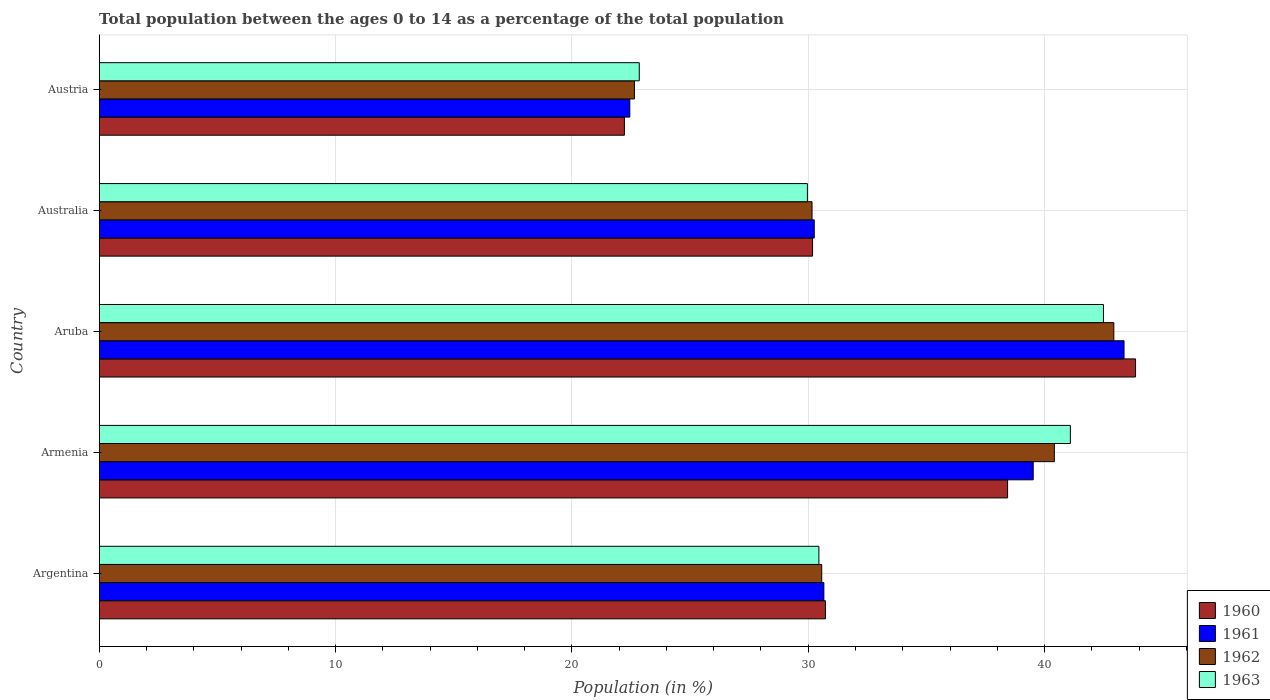How many different coloured bars are there?
Offer a very short reply. 4. How many bars are there on the 3rd tick from the bottom?
Keep it short and to the point. 4. What is the label of the 4th group of bars from the top?
Your answer should be compact. Armenia. What is the percentage of the population ages 0 to 14 in 1961 in Austria?
Offer a terse response. 22.45. Across all countries, what is the maximum percentage of the population ages 0 to 14 in 1962?
Provide a succinct answer. 42.93. Across all countries, what is the minimum percentage of the population ages 0 to 14 in 1962?
Your answer should be compact. 22.64. In which country was the percentage of the population ages 0 to 14 in 1961 maximum?
Offer a very short reply. Aruba. In which country was the percentage of the population ages 0 to 14 in 1960 minimum?
Ensure brevity in your answer.  Austria. What is the total percentage of the population ages 0 to 14 in 1960 in the graph?
Your response must be concise. 165.41. What is the difference between the percentage of the population ages 0 to 14 in 1960 in Armenia and that in Aruba?
Your answer should be very brief. -5.41. What is the difference between the percentage of the population ages 0 to 14 in 1960 in Argentina and the percentage of the population ages 0 to 14 in 1963 in Australia?
Ensure brevity in your answer.  0.76. What is the average percentage of the population ages 0 to 14 in 1963 per country?
Your response must be concise. 33.37. What is the difference between the percentage of the population ages 0 to 14 in 1963 and percentage of the population ages 0 to 14 in 1960 in Argentina?
Your answer should be very brief. -0.28. What is the ratio of the percentage of the population ages 0 to 14 in 1960 in Argentina to that in Armenia?
Offer a terse response. 0.8. Is the percentage of the population ages 0 to 14 in 1962 in Australia less than that in Austria?
Provide a succinct answer. No. Is the difference between the percentage of the population ages 0 to 14 in 1963 in Armenia and Aruba greater than the difference between the percentage of the population ages 0 to 14 in 1960 in Armenia and Aruba?
Give a very brief answer. Yes. What is the difference between the highest and the second highest percentage of the population ages 0 to 14 in 1960?
Your answer should be compact. 5.41. What is the difference between the highest and the lowest percentage of the population ages 0 to 14 in 1963?
Ensure brevity in your answer.  19.64. In how many countries, is the percentage of the population ages 0 to 14 in 1961 greater than the average percentage of the population ages 0 to 14 in 1961 taken over all countries?
Make the answer very short. 2. How many bars are there?
Ensure brevity in your answer.  20. Are all the bars in the graph horizontal?
Offer a terse response. Yes. How many countries are there in the graph?
Your answer should be very brief. 5. Does the graph contain any zero values?
Provide a succinct answer. No. How are the legend labels stacked?
Your answer should be very brief. Vertical. What is the title of the graph?
Provide a succinct answer. Total population between the ages 0 to 14 as a percentage of the total population. Does "1998" appear as one of the legend labels in the graph?
Provide a short and direct response. No. What is the label or title of the X-axis?
Your answer should be compact. Population (in %). What is the label or title of the Y-axis?
Ensure brevity in your answer.  Country. What is the Population (in %) in 1960 in Argentina?
Ensure brevity in your answer.  30.73. What is the Population (in %) of 1961 in Argentina?
Your response must be concise. 30.66. What is the Population (in %) in 1962 in Argentina?
Keep it short and to the point. 30.57. What is the Population (in %) in 1963 in Argentina?
Your response must be concise. 30.45. What is the Population (in %) in 1960 in Armenia?
Your answer should be compact. 38.43. What is the Population (in %) of 1961 in Armenia?
Ensure brevity in your answer.  39.52. What is the Population (in %) in 1962 in Armenia?
Ensure brevity in your answer.  40.41. What is the Population (in %) of 1963 in Armenia?
Ensure brevity in your answer.  41.09. What is the Population (in %) in 1960 in Aruba?
Offer a very short reply. 43.85. What is the Population (in %) of 1961 in Aruba?
Provide a short and direct response. 43.36. What is the Population (in %) in 1962 in Aruba?
Make the answer very short. 42.93. What is the Population (in %) of 1963 in Aruba?
Your response must be concise. 42.49. What is the Population (in %) in 1960 in Australia?
Your answer should be compact. 30.18. What is the Population (in %) of 1961 in Australia?
Keep it short and to the point. 30.25. What is the Population (in %) in 1962 in Australia?
Give a very brief answer. 30.16. What is the Population (in %) of 1963 in Australia?
Provide a succinct answer. 29.96. What is the Population (in %) in 1960 in Austria?
Your answer should be very brief. 22.22. What is the Population (in %) in 1961 in Austria?
Provide a short and direct response. 22.45. What is the Population (in %) in 1962 in Austria?
Make the answer very short. 22.64. What is the Population (in %) in 1963 in Austria?
Offer a very short reply. 22.85. Across all countries, what is the maximum Population (in %) in 1960?
Provide a short and direct response. 43.85. Across all countries, what is the maximum Population (in %) of 1961?
Offer a terse response. 43.36. Across all countries, what is the maximum Population (in %) of 1962?
Provide a short and direct response. 42.93. Across all countries, what is the maximum Population (in %) of 1963?
Your answer should be compact. 42.49. Across all countries, what is the minimum Population (in %) in 1960?
Ensure brevity in your answer.  22.22. Across all countries, what is the minimum Population (in %) in 1961?
Keep it short and to the point. 22.45. Across all countries, what is the minimum Population (in %) of 1962?
Keep it short and to the point. 22.64. Across all countries, what is the minimum Population (in %) of 1963?
Offer a terse response. 22.85. What is the total Population (in %) in 1960 in the graph?
Provide a succinct answer. 165.41. What is the total Population (in %) of 1961 in the graph?
Your answer should be compact. 166.24. What is the total Population (in %) of 1962 in the graph?
Your answer should be very brief. 166.71. What is the total Population (in %) in 1963 in the graph?
Your answer should be compact. 166.84. What is the difference between the Population (in %) in 1960 in Argentina and that in Armenia?
Make the answer very short. -7.71. What is the difference between the Population (in %) of 1961 in Argentina and that in Armenia?
Your answer should be very brief. -8.86. What is the difference between the Population (in %) of 1962 in Argentina and that in Armenia?
Provide a succinct answer. -9.84. What is the difference between the Population (in %) in 1963 in Argentina and that in Armenia?
Give a very brief answer. -10.64. What is the difference between the Population (in %) of 1960 in Argentina and that in Aruba?
Offer a very short reply. -13.12. What is the difference between the Population (in %) in 1961 in Argentina and that in Aruba?
Provide a short and direct response. -12.7. What is the difference between the Population (in %) of 1962 in Argentina and that in Aruba?
Give a very brief answer. -12.36. What is the difference between the Population (in %) of 1963 in Argentina and that in Aruba?
Your answer should be compact. -12.04. What is the difference between the Population (in %) of 1960 in Argentina and that in Australia?
Give a very brief answer. 0.54. What is the difference between the Population (in %) of 1961 in Argentina and that in Australia?
Ensure brevity in your answer.  0.41. What is the difference between the Population (in %) in 1962 in Argentina and that in Australia?
Provide a succinct answer. 0.41. What is the difference between the Population (in %) in 1963 in Argentina and that in Australia?
Keep it short and to the point. 0.49. What is the difference between the Population (in %) in 1960 in Argentina and that in Austria?
Your response must be concise. 8.5. What is the difference between the Population (in %) of 1961 in Argentina and that in Austria?
Provide a succinct answer. 8.21. What is the difference between the Population (in %) in 1962 in Argentina and that in Austria?
Provide a short and direct response. 7.92. What is the difference between the Population (in %) in 1963 in Argentina and that in Austria?
Your answer should be very brief. 7.6. What is the difference between the Population (in %) in 1960 in Armenia and that in Aruba?
Your answer should be compact. -5.41. What is the difference between the Population (in %) in 1961 in Armenia and that in Aruba?
Provide a succinct answer. -3.84. What is the difference between the Population (in %) in 1962 in Armenia and that in Aruba?
Your response must be concise. -2.52. What is the difference between the Population (in %) in 1963 in Armenia and that in Aruba?
Ensure brevity in your answer.  -1.4. What is the difference between the Population (in %) in 1960 in Armenia and that in Australia?
Give a very brief answer. 8.25. What is the difference between the Population (in %) in 1961 in Armenia and that in Australia?
Your answer should be compact. 9.26. What is the difference between the Population (in %) of 1962 in Armenia and that in Australia?
Provide a short and direct response. 10.25. What is the difference between the Population (in %) of 1963 in Armenia and that in Australia?
Your answer should be compact. 11.13. What is the difference between the Population (in %) in 1960 in Armenia and that in Austria?
Provide a short and direct response. 16.21. What is the difference between the Population (in %) of 1961 in Armenia and that in Austria?
Offer a very short reply. 17.07. What is the difference between the Population (in %) in 1962 in Armenia and that in Austria?
Provide a succinct answer. 17.77. What is the difference between the Population (in %) of 1963 in Armenia and that in Austria?
Make the answer very short. 18.24. What is the difference between the Population (in %) in 1960 in Aruba and that in Australia?
Provide a short and direct response. 13.67. What is the difference between the Population (in %) of 1961 in Aruba and that in Australia?
Give a very brief answer. 13.11. What is the difference between the Population (in %) in 1962 in Aruba and that in Australia?
Give a very brief answer. 12.77. What is the difference between the Population (in %) in 1963 in Aruba and that in Australia?
Your answer should be very brief. 12.53. What is the difference between the Population (in %) of 1960 in Aruba and that in Austria?
Offer a very short reply. 21.63. What is the difference between the Population (in %) in 1961 in Aruba and that in Austria?
Offer a terse response. 20.91. What is the difference between the Population (in %) in 1962 in Aruba and that in Austria?
Offer a terse response. 20.28. What is the difference between the Population (in %) in 1963 in Aruba and that in Austria?
Ensure brevity in your answer.  19.64. What is the difference between the Population (in %) in 1960 in Australia and that in Austria?
Provide a short and direct response. 7.96. What is the difference between the Population (in %) of 1961 in Australia and that in Austria?
Give a very brief answer. 7.8. What is the difference between the Population (in %) of 1962 in Australia and that in Austria?
Give a very brief answer. 7.51. What is the difference between the Population (in %) of 1963 in Australia and that in Austria?
Give a very brief answer. 7.11. What is the difference between the Population (in %) of 1960 in Argentina and the Population (in %) of 1961 in Armenia?
Give a very brief answer. -8.79. What is the difference between the Population (in %) in 1960 in Argentina and the Population (in %) in 1962 in Armenia?
Provide a short and direct response. -9.69. What is the difference between the Population (in %) in 1960 in Argentina and the Population (in %) in 1963 in Armenia?
Offer a very short reply. -10.36. What is the difference between the Population (in %) of 1961 in Argentina and the Population (in %) of 1962 in Armenia?
Give a very brief answer. -9.75. What is the difference between the Population (in %) of 1961 in Argentina and the Population (in %) of 1963 in Armenia?
Your answer should be very brief. -10.43. What is the difference between the Population (in %) in 1962 in Argentina and the Population (in %) in 1963 in Armenia?
Give a very brief answer. -10.52. What is the difference between the Population (in %) in 1960 in Argentina and the Population (in %) in 1961 in Aruba?
Offer a terse response. -12.64. What is the difference between the Population (in %) of 1960 in Argentina and the Population (in %) of 1962 in Aruba?
Offer a terse response. -12.2. What is the difference between the Population (in %) of 1960 in Argentina and the Population (in %) of 1963 in Aruba?
Provide a short and direct response. -11.76. What is the difference between the Population (in %) of 1961 in Argentina and the Population (in %) of 1962 in Aruba?
Your answer should be very brief. -12.27. What is the difference between the Population (in %) of 1961 in Argentina and the Population (in %) of 1963 in Aruba?
Keep it short and to the point. -11.83. What is the difference between the Population (in %) in 1962 in Argentina and the Population (in %) in 1963 in Aruba?
Give a very brief answer. -11.92. What is the difference between the Population (in %) of 1960 in Argentina and the Population (in %) of 1961 in Australia?
Offer a very short reply. 0.47. What is the difference between the Population (in %) in 1960 in Argentina and the Population (in %) in 1962 in Australia?
Make the answer very short. 0.57. What is the difference between the Population (in %) in 1960 in Argentina and the Population (in %) in 1963 in Australia?
Your answer should be compact. 0.76. What is the difference between the Population (in %) of 1961 in Argentina and the Population (in %) of 1962 in Australia?
Ensure brevity in your answer.  0.5. What is the difference between the Population (in %) in 1961 in Argentina and the Population (in %) in 1963 in Australia?
Provide a short and direct response. 0.7. What is the difference between the Population (in %) in 1962 in Argentina and the Population (in %) in 1963 in Australia?
Provide a succinct answer. 0.61. What is the difference between the Population (in %) of 1960 in Argentina and the Population (in %) of 1961 in Austria?
Give a very brief answer. 8.28. What is the difference between the Population (in %) in 1960 in Argentina and the Population (in %) in 1962 in Austria?
Ensure brevity in your answer.  8.08. What is the difference between the Population (in %) in 1960 in Argentina and the Population (in %) in 1963 in Austria?
Provide a succinct answer. 7.88. What is the difference between the Population (in %) in 1961 in Argentina and the Population (in %) in 1962 in Austria?
Provide a short and direct response. 8.02. What is the difference between the Population (in %) of 1961 in Argentina and the Population (in %) of 1963 in Austria?
Offer a very short reply. 7.81. What is the difference between the Population (in %) of 1962 in Argentina and the Population (in %) of 1963 in Austria?
Give a very brief answer. 7.72. What is the difference between the Population (in %) in 1960 in Armenia and the Population (in %) in 1961 in Aruba?
Make the answer very short. -4.93. What is the difference between the Population (in %) of 1960 in Armenia and the Population (in %) of 1962 in Aruba?
Provide a succinct answer. -4.49. What is the difference between the Population (in %) in 1960 in Armenia and the Population (in %) in 1963 in Aruba?
Your response must be concise. -4.05. What is the difference between the Population (in %) of 1961 in Armenia and the Population (in %) of 1962 in Aruba?
Ensure brevity in your answer.  -3.41. What is the difference between the Population (in %) of 1961 in Armenia and the Population (in %) of 1963 in Aruba?
Provide a short and direct response. -2.97. What is the difference between the Population (in %) of 1962 in Armenia and the Population (in %) of 1963 in Aruba?
Ensure brevity in your answer.  -2.08. What is the difference between the Population (in %) in 1960 in Armenia and the Population (in %) in 1961 in Australia?
Provide a short and direct response. 8.18. What is the difference between the Population (in %) in 1960 in Armenia and the Population (in %) in 1962 in Australia?
Offer a very short reply. 8.27. What is the difference between the Population (in %) in 1960 in Armenia and the Population (in %) in 1963 in Australia?
Offer a very short reply. 8.47. What is the difference between the Population (in %) in 1961 in Armenia and the Population (in %) in 1962 in Australia?
Your answer should be very brief. 9.36. What is the difference between the Population (in %) in 1961 in Armenia and the Population (in %) in 1963 in Australia?
Your answer should be very brief. 9.55. What is the difference between the Population (in %) in 1962 in Armenia and the Population (in %) in 1963 in Australia?
Ensure brevity in your answer.  10.45. What is the difference between the Population (in %) in 1960 in Armenia and the Population (in %) in 1961 in Austria?
Your answer should be very brief. 15.98. What is the difference between the Population (in %) in 1960 in Armenia and the Population (in %) in 1962 in Austria?
Keep it short and to the point. 15.79. What is the difference between the Population (in %) of 1960 in Armenia and the Population (in %) of 1963 in Austria?
Your answer should be very brief. 15.58. What is the difference between the Population (in %) in 1961 in Armenia and the Population (in %) in 1962 in Austria?
Your response must be concise. 16.87. What is the difference between the Population (in %) of 1961 in Armenia and the Population (in %) of 1963 in Austria?
Give a very brief answer. 16.67. What is the difference between the Population (in %) of 1962 in Armenia and the Population (in %) of 1963 in Austria?
Ensure brevity in your answer.  17.56. What is the difference between the Population (in %) of 1960 in Aruba and the Population (in %) of 1961 in Australia?
Provide a succinct answer. 13.59. What is the difference between the Population (in %) in 1960 in Aruba and the Population (in %) in 1962 in Australia?
Offer a terse response. 13.69. What is the difference between the Population (in %) of 1960 in Aruba and the Population (in %) of 1963 in Australia?
Make the answer very short. 13.88. What is the difference between the Population (in %) of 1961 in Aruba and the Population (in %) of 1962 in Australia?
Provide a short and direct response. 13.2. What is the difference between the Population (in %) of 1961 in Aruba and the Population (in %) of 1963 in Australia?
Offer a very short reply. 13.4. What is the difference between the Population (in %) in 1962 in Aruba and the Population (in %) in 1963 in Australia?
Your answer should be very brief. 12.97. What is the difference between the Population (in %) in 1960 in Aruba and the Population (in %) in 1961 in Austria?
Your answer should be compact. 21.4. What is the difference between the Population (in %) in 1960 in Aruba and the Population (in %) in 1962 in Austria?
Your answer should be very brief. 21.2. What is the difference between the Population (in %) of 1960 in Aruba and the Population (in %) of 1963 in Austria?
Make the answer very short. 21. What is the difference between the Population (in %) in 1961 in Aruba and the Population (in %) in 1962 in Austria?
Your answer should be compact. 20.72. What is the difference between the Population (in %) of 1961 in Aruba and the Population (in %) of 1963 in Austria?
Ensure brevity in your answer.  20.51. What is the difference between the Population (in %) in 1962 in Aruba and the Population (in %) in 1963 in Austria?
Provide a succinct answer. 20.08. What is the difference between the Population (in %) in 1960 in Australia and the Population (in %) in 1961 in Austria?
Your answer should be very brief. 7.73. What is the difference between the Population (in %) of 1960 in Australia and the Population (in %) of 1962 in Austria?
Make the answer very short. 7.54. What is the difference between the Population (in %) in 1960 in Australia and the Population (in %) in 1963 in Austria?
Keep it short and to the point. 7.33. What is the difference between the Population (in %) of 1961 in Australia and the Population (in %) of 1962 in Austria?
Give a very brief answer. 7.61. What is the difference between the Population (in %) in 1961 in Australia and the Population (in %) in 1963 in Austria?
Your answer should be compact. 7.4. What is the difference between the Population (in %) in 1962 in Australia and the Population (in %) in 1963 in Austria?
Make the answer very short. 7.31. What is the average Population (in %) of 1960 per country?
Offer a terse response. 33.08. What is the average Population (in %) of 1961 per country?
Your answer should be compact. 33.25. What is the average Population (in %) in 1962 per country?
Ensure brevity in your answer.  33.34. What is the average Population (in %) of 1963 per country?
Ensure brevity in your answer.  33.37. What is the difference between the Population (in %) of 1960 and Population (in %) of 1961 in Argentina?
Offer a very short reply. 0.07. What is the difference between the Population (in %) of 1960 and Population (in %) of 1962 in Argentina?
Ensure brevity in your answer.  0.16. What is the difference between the Population (in %) in 1960 and Population (in %) in 1963 in Argentina?
Provide a short and direct response. 0.28. What is the difference between the Population (in %) in 1961 and Population (in %) in 1962 in Argentina?
Give a very brief answer. 0.09. What is the difference between the Population (in %) of 1961 and Population (in %) of 1963 in Argentina?
Offer a very short reply. 0.21. What is the difference between the Population (in %) of 1962 and Population (in %) of 1963 in Argentina?
Your response must be concise. 0.12. What is the difference between the Population (in %) in 1960 and Population (in %) in 1961 in Armenia?
Keep it short and to the point. -1.08. What is the difference between the Population (in %) of 1960 and Population (in %) of 1962 in Armenia?
Provide a succinct answer. -1.98. What is the difference between the Population (in %) in 1960 and Population (in %) in 1963 in Armenia?
Offer a very short reply. -2.66. What is the difference between the Population (in %) of 1961 and Population (in %) of 1962 in Armenia?
Your answer should be compact. -0.89. What is the difference between the Population (in %) in 1961 and Population (in %) in 1963 in Armenia?
Offer a very short reply. -1.57. What is the difference between the Population (in %) of 1962 and Population (in %) of 1963 in Armenia?
Offer a terse response. -0.68. What is the difference between the Population (in %) in 1960 and Population (in %) in 1961 in Aruba?
Your response must be concise. 0.49. What is the difference between the Population (in %) in 1960 and Population (in %) in 1962 in Aruba?
Provide a short and direct response. 0.92. What is the difference between the Population (in %) in 1960 and Population (in %) in 1963 in Aruba?
Provide a succinct answer. 1.36. What is the difference between the Population (in %) of 1961 and Population (in %) of 1962 in Aruba?
Your answer should be compact. 0.43. What is the difference between the Population (in %) of 1961 and Population (in %) of 1963 in Aruba?
Provide a short and direct response. 0.87. What is the difference between the Population (in %) of 1962 and Population (in %) of 1963 in Aruba?
Make the answer very short. 0.44. What is the difference between the Population (in %) in 1960 and Population (in %) in 1961 in Australia?
Provide a short and direct response. -0.07. What is the difference between the Population (in %) in 1960 and Population (in %) in 1962 in Australia?
Your response must be concise. 0.02. What is the difference between the Population (in %) in 1960 and Population (in %) in 1963 in Australia?
Provide a succinct answer. 0.22. What is the difference between the Population (in %) of 1961 and Population (in %) of 1962 in Australia?
Give a very brief answer. 0.09. What is the difference between the Population (in %) of 1961 and Population (in %) of 1963 in Australia?
Ensure brevity in your answer.  0.29. What is the difference between the Population (in %) in 1962 and Population (in %) in 1963 in Australia?
Make the answer very short. 0.2. What is the difference between the Population (in %) of 1960 and Population (in %) of 1961 in Austria?
Your response must be concise. -0.23. What is the difference between the Population (in %) in 1960 and Population (in %) in 1962 in Austria?
Make the answer very short. -0.42. What is the difference between the Population (in %) of 1960 and Population (in %) of 1963 in Austria?
Ensure brevity in your answer.  -0.63. What is the difference between the Population (in %) in 1961 and Population (in %) in 1962 in Austria?
Make the answer very short. -0.2. What is the difference between the Population (in %) of 1961 and Population (in %) of 1963 in Austria?
Ensure brevity in your answer.  -0.4. What is the difference between the Population (in %) in 1962 and Population (in %) in 1963 in Austria?
Your answer should be very brief. -0.2. What is the ratio of the Population (in %) of 1960 in Argentina to that in Armenia?
Give a very brief answer. 0.8. What is the ratio of the Population (in %) of 1961 in Argentina to that in Armenia?
Your answer should be compact. 0.78. What is the ratio of the Population (in %) in 1962 in Argentina to that in Armenia?
Ensure brevity in your answer.  0.76. What is the ratio of the Population (in %) of 1963 in Argentina to that in Armenia?
Ensure brevity in your answer.  0.74. What is the ratio of the Population (in %) of 1960 in Argentina to that in Aruba?
Keep it short and to the point. 0.7. What is the ratio of the Population (in %) of 1961 in Argentina to that in Aruba?
Give a very brief answer. 0.71. What is the ratio of the Population (in %) in 1962 in Argentina to that in Aruba?
Ensure brevity in your answer.  0.71. What is the ratio of the Population (in %) in 1963 in Argentina to that in Aruba?
Give a very brief answer. 0.72. What is the ratio of the Population (in %) of 1960 in Argentina to that in Australia?
Provide a short and direct response. 1.02. What is the ratio of the Population (in %) in 1961 in Argentina to that in Australia?
Make the answer very short. 1.01. What is the ratio of the Population (in %) in 1962 in Argentina to that in Australia?
Give a very brief answer. 1.01. What is the ratio of the Population (in %) of 1963 in Argentina to that in Australia?
Offer a terse response. 1.02. What is the ratio of the Population (in %) in 1960 in Argentina to that in Austria?
Keep it short and to the point. 1.38. What is the ratio of the Population (in %) of 1961 in Argentina to that in Austria?
Your response must be concise. 1.37. What is the ratio of the Population (in %) in 1962 in Argentina to that in Austria?
Make the answer very short. 1.35. What is the ratio of the Population (in %) in 1963 in Argentina to that in Austria?
Provide a succinct answer. 1.33. What is the ratio of the Population (in %) in 1960 in Armenia to that in Aruba?
Make the answer very short. 0.88. What is the ratio of the Population (in %) of 1961 in Armenia to that in Aruba?
Provide a succinct answer. 0.91. What is the ratio of the Population (in %) in 1962 in Armenia to that in Aruba?
Provide a short and direct response. 0.94. What is the ratio of the Population (in %) in 1963 in Armenia to that in Aruba?
Offer a very short reply. 0.97. What is the ratio of the Population (in %) of 1960 in Armenia to that in Australia?
Make the answer very short. 1.27. What is the ratio of the Population (in %) of 1961 in Armenia to that in Australia?
Keep it short and to the point. 1.31. What is the ratio of the Population (in %) of 1962 in Armenia to that in Australia?
Ensure brevity in your answer.  1.34. What is the ratio of the Population (in %) in 1963 in Armenia to that in Australia?
Make the answer very short. 1.37. What is the ratio of the Population (in %) in 1960 in Armenia to that in Austria?
Your response must be concise. 1.73. What is the ratio of the Population (in %) in 1961 in Armenia to that in Austria?
Ensure brevity in your answer.  1.76. What is the ratio of the Population (in %) in 1962 in Armenia to that in Austria?
Your response must be concise. 1.78. What is the ratio of the Population (in %) of 1963 in Armenia to that in Austria?
Provide a succinct answer. 1.8. What is the ratio of the Population (in %) of 1960 in Aruba to that in Australia?
Your answer should be very brief. 1.45. What is the ratio of the Population (in %) in 1961 in Aruba to that in Australia?
Provide a succinct answer. 1.43. What is the ratio of the Population (in %) in 1962 in Aruba to that in Australia?
Keep it short and to the point. 1.42. What is the ratio of the Population (in %) in 1963 in Aruba to that in Australia?
Make the answer very short. 1.42. What is the ratio of the Population (in %) of 1960 in Aruba to that in Austria?
Your answer should be very brief. 1.97. What is the ratio of the Population (in %) of 1961 in Aruba to that in Austria?
Offer a terse response. 1.93. What is the ratio of the Population (in %) in 1962 in Aruba to that in Austria?
Provide a succinct answer. 1.9. What is the ratio of the Population (in %) of 1963 in Aruba to that in Austria?
Offer a terse response. 1.86. What is the ratio of the Population (in %) of 1960 in Australia to that in Austria?
Provide a short and direct response. 1.36. What is the ratio of the Population (in %) in 1961 in Australia to that in Austria?
Your answer should be very brief. 1.35. What is the ratio of the Population (in %) of 1962 in Australia to that in Austria?
Provide a short and direct response. 1.33. What is the ratio of the Population (in %) in 1963 in Australia to that in Austria?
Offer a terse response. 1.31. What is the difference between the highest and the second highest Population (in %) in 1960?
Your response must be concise. 5.41. What is the difference between the highest and the second highest Population (in %) of 1961?
Keep it short and to the point. 3.84. What is the difference between the highest and the second highest Population (in %) of 1962?
Provide a short and direct response. 2.52. What is the difference between the highest and the second highest Population (in %) in 1963?
Your answer should be compact. 1.4. What is the difference between the highest and the lowest Population (in %) of 1960?
Provide a short and direct response. 21.63. What is the difference between the highest and the lowest Population (in %) in 1961?
Keep it short and to the point. 20.91. What is the difference between the highest and the lowest Population (in %) of 1962?
Your answer should be compact. 20.28. What is the difference between the highest and the lowest Population (in %) in 1963?
Ensure brevity in your answer.  19.64. 